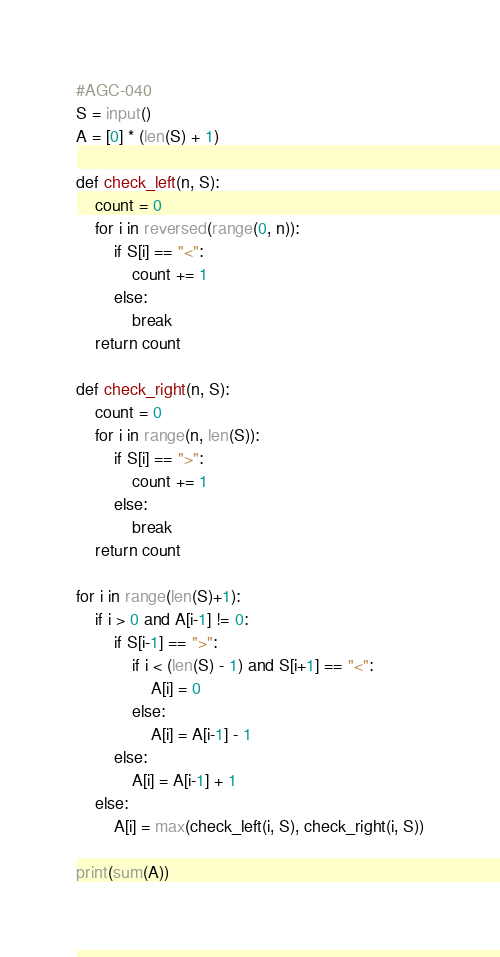Convert code to text. <code><loc_0><loc_0><loc_500><loc_500><_Python_>#AGC-040
S = input()
A = [0] * (len(S) + 1)

def check_left(n, S):
    count = 0
    for i in reversed(range(0, n)):
        if S[i] == "<":
            count += 1
        else:
            break
    return count

def check_right(n, S):
    count = 0
    for i in range(n, len(S)):
        if S[i] == ">":
            count += 1
        else:
            break
    return count

for i in range(len(S)+1):
    if i > 0 and A[i-1] != 0:
        if S[i-1] == ">":
            if i < (len(S) - 1) and S[i+1] == "<":
                A[i] = 0
            else:
                A[i] = A[i-1] - 1
        else:
            A[i] = A[i-1] + 1
    else:
        A[i] = max(check_left(i, S), check_right(i, S))
    
print(sum(A))</code> 